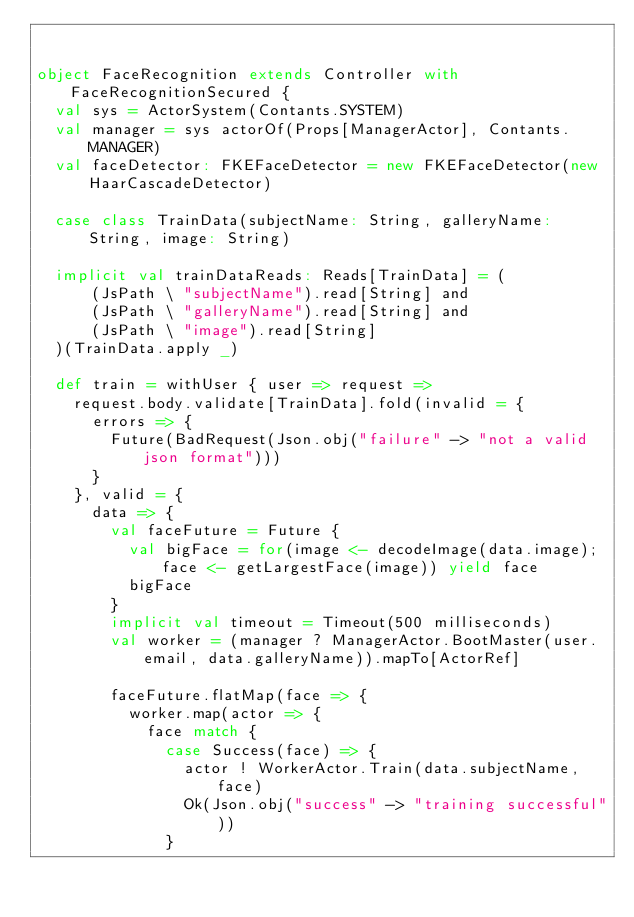<code> <loc_0><loc_0><loc_500><loc_500><_Scala_>

object FaceRecognition extends Controller with FaceRecognitionSecured {
  val sys = ActorSystem(Contants.SYSTEM)
  val manager = sys actorOf(Props[ManagerActor], Contants.MANAGER)
  val faceDetector: FKEFaceDetector = new FKEFaceDetector(new HaarCascadeDetector)
  
  case class TrainData(subjectName: String, galleryName: String, image: String)
  
  implicit val trainDataReads: Reads[TrainData] = (
      (JsPath \ "subjectName").read[String] and
      (JsPath \ "galleryName").read[String] and
      (JsPath \ "image").read[String]
  )(TrainData.apply _)
  
  def train = withUser { user => request =>
    request.body.validate[TrainData].fold(invalid = {
      errors => {
        Future(BadRequest(Json.obj("failure" -> "not a valid json format")))
      }
    }, valid = {
      data => {
        val faceFuture = Future {
          val bigFace = for(image <- decodeImage(data.image); face <- getLargestFace(image)) yield face
          bigFace
        }
        implicit val timeout = Timeout(500 milliseconds)
        val worker = (manager ? ManagerActor.BootMaster(user.email, data.galleryName)).mapTo[ActorRef]
        
        faceFuture.flatMap(face => {
          worker.map(actor => {
            face match {
              case Success(face) => {
                actor ! WorkerActor.Train(data.subjectName, face)
                Ok(Json.obj("success" -> "training successful"))
              }</code> 